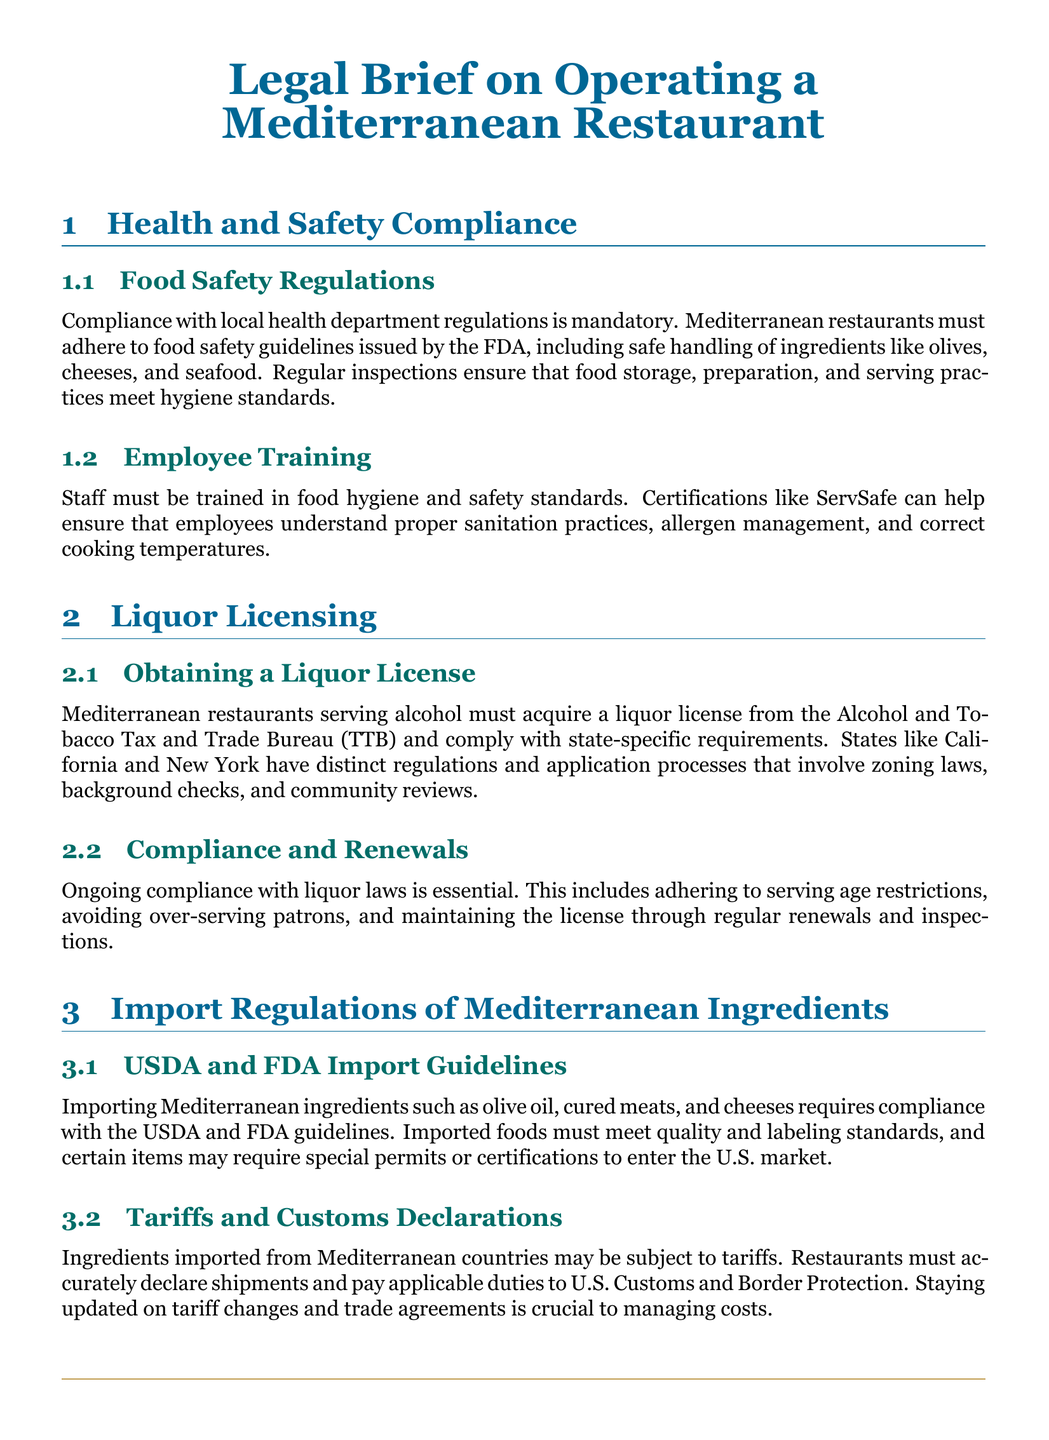What is mandatory for Mediterranean restaurants? Compliance with local health department regulations is crucial for operating Mediterranean restaurants.
Answer: Compliance with local health department regulations What certification can staff obtain for food hygiene? Staff training can be validated through certifications like ServSafe for food hygiene knowledge.
Answer: ServSafe Which bureau regulates liquor licenses? The Alcohol and Tobacco Tax and Trade Bureau is responsible for liquor licensing rules.
Answer: Alcohol and Tobacco Tax and Trade Bureau What must be renewed regularly to maintain compliance? Mediterranean restaurants must regularly renew their liquor licenses to stay compliant.
Answer: Liquor licenses Which ingredients require compliance with import guidelines? Mediterranean ingredients like olive oil and cured meats must adhere to USDA and FDA import guidelines.
Answer: Olive oil, cured meats What is crucial for managing costs related to imports? Staying updated on tariffs and trade agreements is key for managing costs on imported ingredients.
Answer: Tariffs and trade agreements What is essential when serving alcohol in restaurants? Adhering to serving age restrictions is a critical consideration when serving alcohol.
Answer: Serving age restrictions What training standard helps ensure proper sanitation practices? Certifications such as ServSafe help ensure that employees are trained in sanitation.
Answer: ServSafe What may be required for imported Mediterranean items? Certain Mediterranean items may need special permits or certifications for import.
Answer: Special permits or certifications 